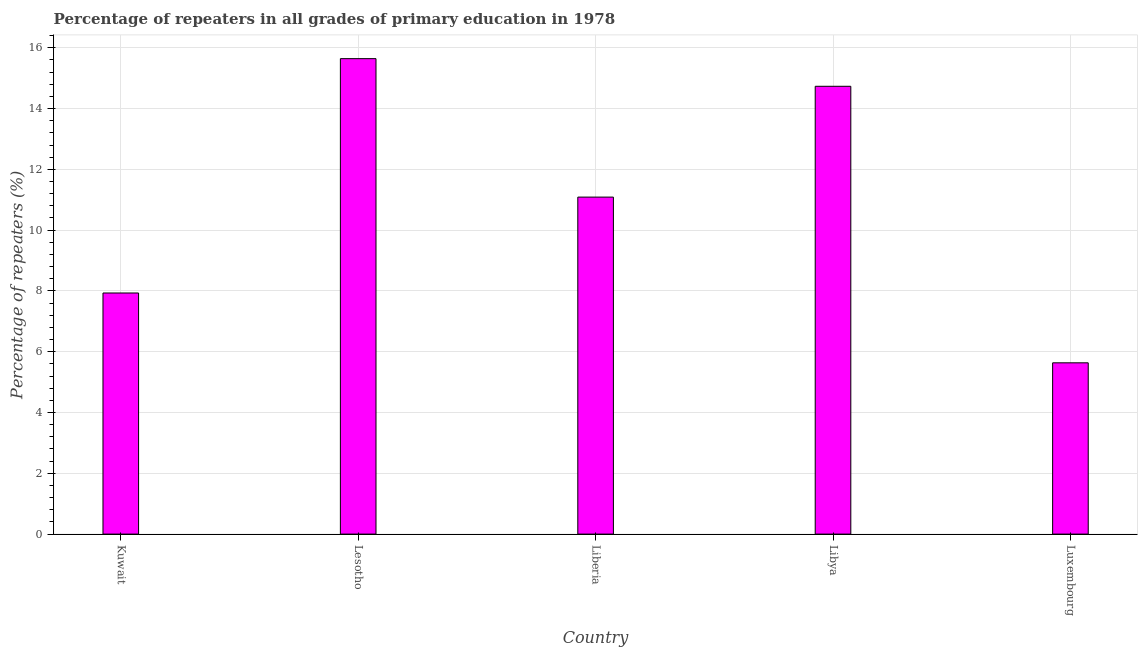Does the graph contain grids?
Provide a short and direct response. Yes. What is the title of the graph?
Your response must be concise. Percentage of repeaters in all grades of primary education in 1978. What is the label or title of the Y-axis?
Ensure brevity in your answer.  Percentage of repeaters (%). What is the percentage of repeaters in primary education in Libya?
Your answer should be very brief. 14.73. Across all countries, what is the maximum percentage of repeaters in primary education?
Your answer should be very brief. 15.64. Across all countries, what is the minimum percentage of repeaters in primary education?
Provide a succinct answer. 5.63. In which country was the percentage of repeaters in primary education maximum?
Offer a terse response. Lesotho. In which country was the percentage of repeaters in primary education minimum?
Make the answer very short. Luxembourg. What is the sum of the percentage of repeaters in primary education?
Make the answer very short. 55.03. What is the difference between the percentage of repeaters in primary education in Liberia and Luxembourg?
Your answer should be compact. 5.45. What is the average percentage of repeaters in primary education per country?
Provide a succinct answer. 11.01. What is the median percentage of repeaters in primary education?
Your answer should be compact. 11.09. What is the ratio of the percentage of repeaters in primary education in Kuwait to that in Lesotho?
Your answer should be compact. 0.51. Is the difference between the percentage of repeaters in primary education in Lesotho and Libya greater than the difference between any two countries?
Provide a succinct answer. No. What is the difference between the highest and the second highest percentage of repeaters in primary education?
Your response must be concise. 0.91. What is the difference between the highest and the lowest percentage of repeaters in primary education?
Offer a very short reply. 10.01. How many bars are there?
Your response must be concise. 5. Are all the bars in the graph horizontal?
Ensure brevity in your answer.  No. How many countries are there in the graph?
Provide a succinct answer. 5. What is the Percentage of repeaters (%) of Kuwait?
Make the answer very short. 7.93. What is the Percentage of repeaters (%) of Lesotho?
Your answer should be very brief. 15.64. What is the Percentage of repeaters (%) of Liberia?
Make the answer very short. 11.09. What is the Percentage of repeaters (%) in Libya?
Your answer should be very brief. 14.73. What is the Percentage of repeaters (%) in Luxembourg?
Provide a succinct answer. 5.63. What is the difference between the Percentage of repeaters (%) in Kuwait and Lesotho?
Offer a very short reply. -7.71. What is the difference between the Percentage of repeaters (%) in Kuwait and Liberia?
Your answer should be very brief. -3.15. What is the difference between the Percentage of repeaters (%) in Kuwait and Libya?
Provide a succinct answer. -6.8. What is the difference between the Percentage of repeaters (%) in Kuwait and Luxembourg?
Offer a very short reply. 2.3. What is the difference between the Percentage of repeaters (%) in Lesotho and Liberia?
Give a very brief answer. 4.56. What is the difference between the Percentage of repeaters (%) in Lesotho and Libya?
Provide a short and direct response. 0.91. What is the difference between the Percentage of repeaters (%) in Lesotho and Luxembourg?
Ensure brevity in your answer.  10.01. What is the difference between the Percentage of repeaters (%) in Liberia and Libya?
Your answer should be very brief. -3.65. What is the difference between the Percentage of repeaters (%) in Liberia and Luxembourg?
Keep it short and to the point. 5.45. What is the difference between the Percentage of repeaters (%) in Libya and Luxembourg?
Ensure brevity in your answer.  9.1. What is the ratio of the Percentage of repeaters (%) in Kuwait to that in Lesotho?
Offer a very short reply. 0.51. What is the ratio of the Percentage of repeaters (%) in Kuwait to that in Liberia?
Make the answer very short. 0.71. What is the ratio of the Percentage of repeaters (%) in Kuwait to that in Libya?
Make the answer very short. 0.54. What is the ratio of the Percentage of repeaters (%) in Kuwait to that in Luxembourg?
Your response must be concise. 1.41. What is the ratio of the Percentage of repeaters (%) in Lesotho to that in Liberia?
Your answer should be very brief. 1.41. What is the ratio of the Percentage of repeaters (%) in Lesotho to that in Libya?
Ensure brevity in your answer.  1.06. What is the ratio of the Percentage of repeaters (%) in Lesotho to that in Luxembourg?
Offer a very short reply. 2.78. What is the ratio of the Percentage of repeaters (%) in Liberia to that in Libya?
Give a very brief answer. 0.75. What is the ratio of the Percentage of repeaters (%) in Liberia to that in Luxembourg?
Provide a succinct answer. 1.97. What is the ratio of the Percentage of repeaters (%) in Libya to that in Luxembourg?
Make the answer very short. 2.62. 